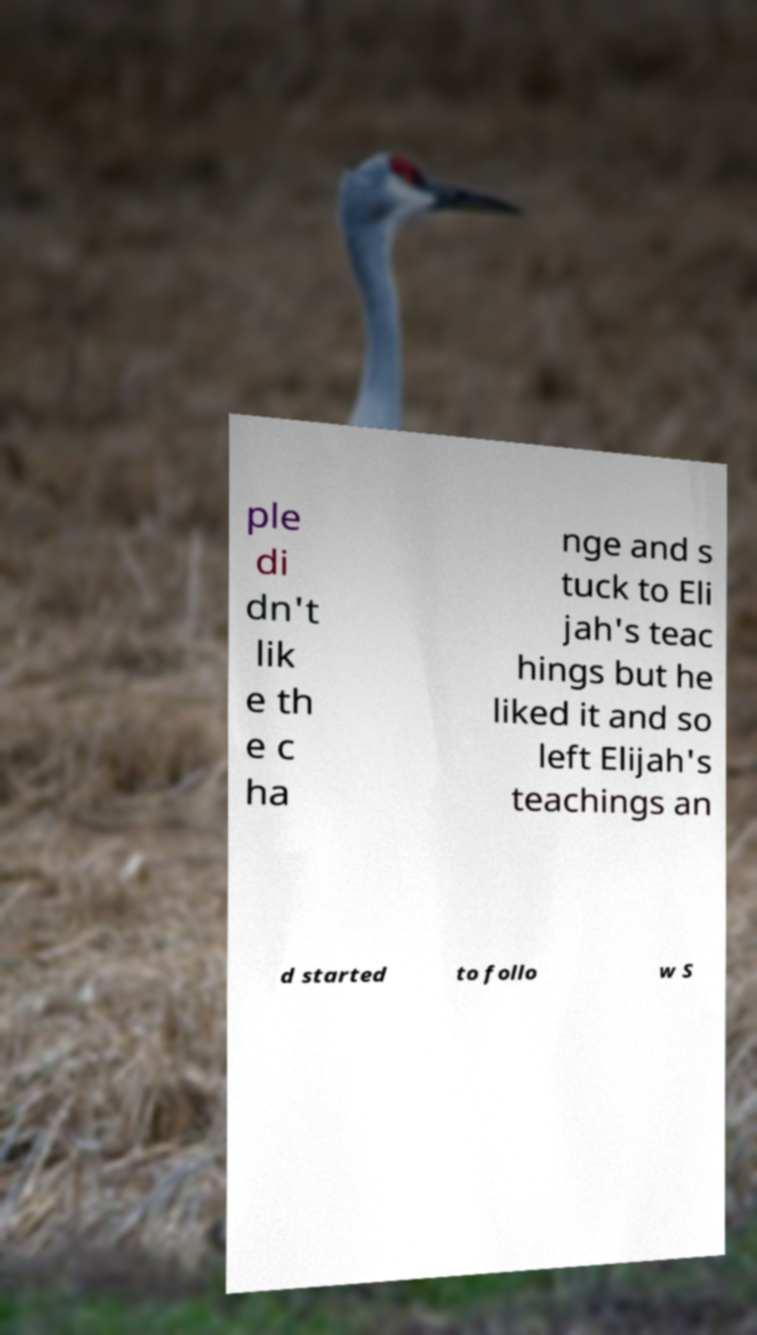For documentation purposes, I need the text within this image transcribed. Could you provide that? ple di dn't lik e th e c ha nge and s tuck to Eli jah's teac hings but he liked it and so left Elijah's teachings an d started to follo w S 